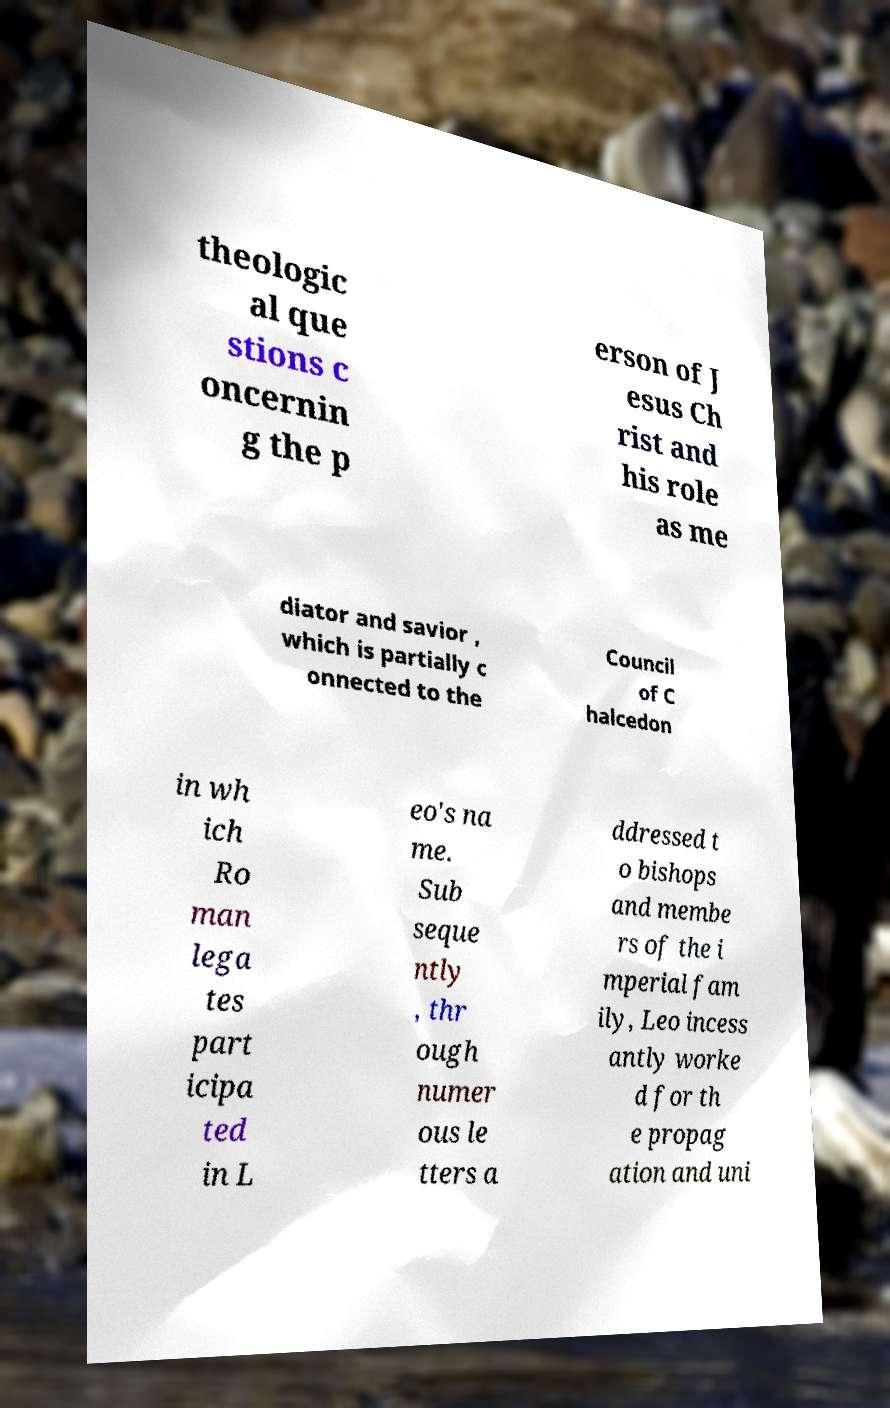Could you extract and type out the text from this image? theologic al que stions c oncernin g the p erson of J esus Ch rist and his role as me diator and savior , which is partially c onnected to the Council of C halcedon in wh ich Ro man lega tes part icipa ted in L eo's na me. Sub seque ntly , thr ough numer ous le tters a ddressed t o bishops and membe rs of the i mperial fam ily, Leo incess antly worke d for th e propag ation and uni 